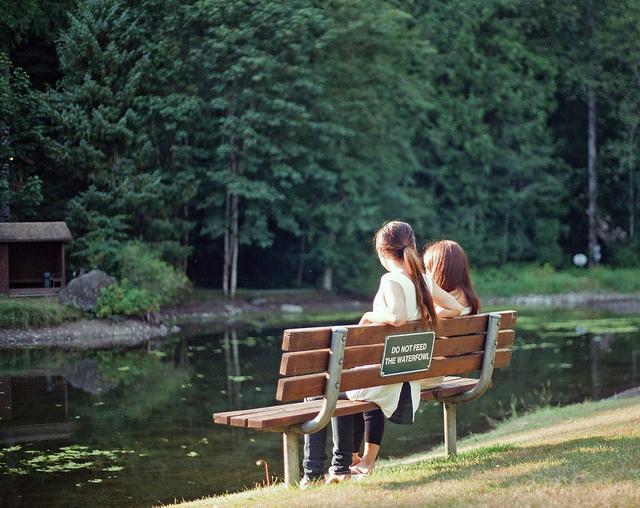How many people are in the picture?
Give a very brief answer. 2. How many benches can you see?
Give a very brief answer. 1. How many people are in the photo?
Give a very brief answer. 2. How many rolls of toilet paper are on the toilet?
Give a very brief answer. 0. 